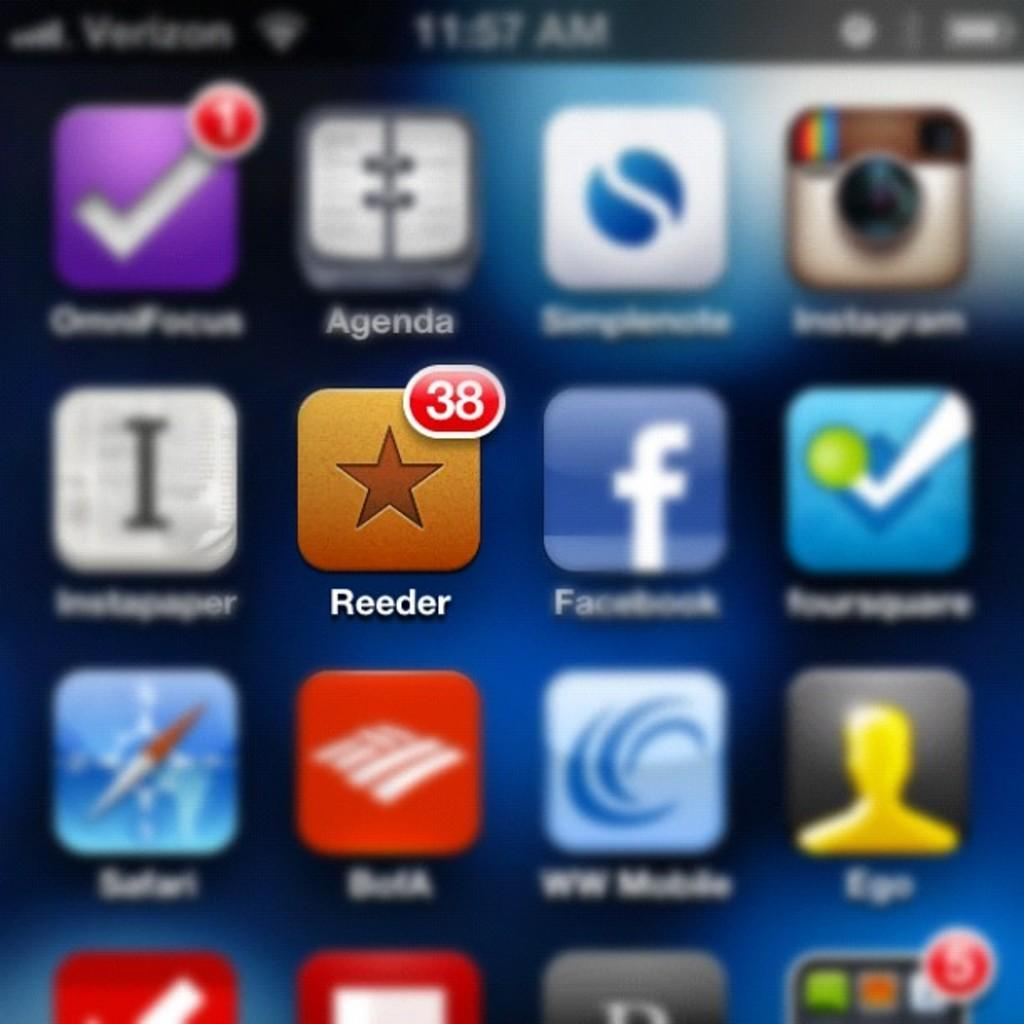<image>
Offer a succinct explanation of the picture presented. A phone displaying lots of apps with the Reeder app in the forefront 